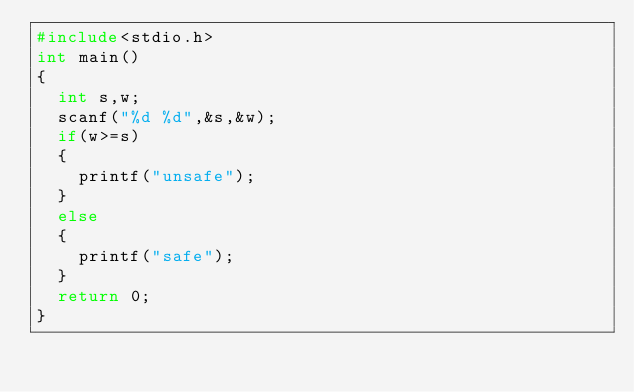Convert code to text. <code><loc_0><loc_0><loc_500><loc_500><_C_>#include<stdio.h>
int main()
{
  int s,w;
  scanf("%d %d",&s,&w);
  if(w>=s)
  {
    printf("unsafe");
  }
  else
  {
    printf("safe");
  }
  return 0;
}</code> 